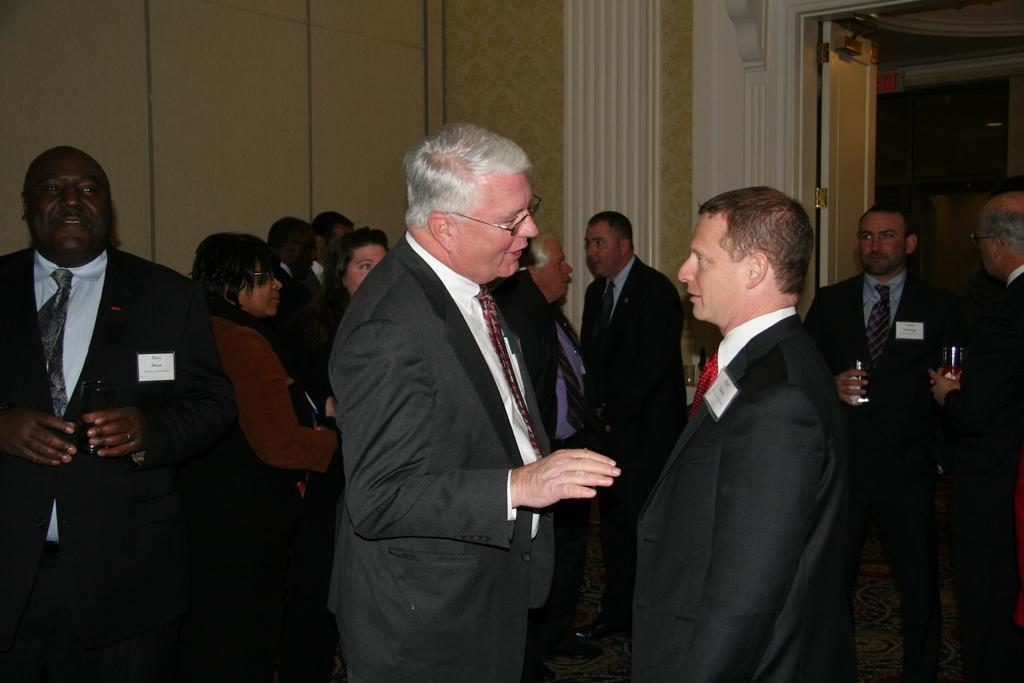Who or what can be seen in the image? There are people in the image. What is behind the people in the image? There is a wall behind the people. Where is the door located in the image? The door is on the right side of the image. What year is depicted in the image? The provided facts do not mention any specific year, so it cannot be determined from the image. Is there a bathtub visible in the image? There is no bathtub present in the image. 